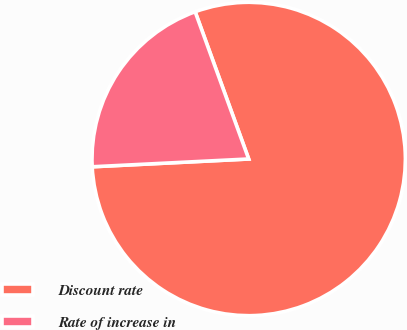Convert chart to OTSL. <chart><loc_0><loc_0><loc_500><loc_500><pie_chart><fcel>Discount rate<fcel>Rate of increase in<nl><fcel>79.76%<fcel>20.24%<nl></chart> 